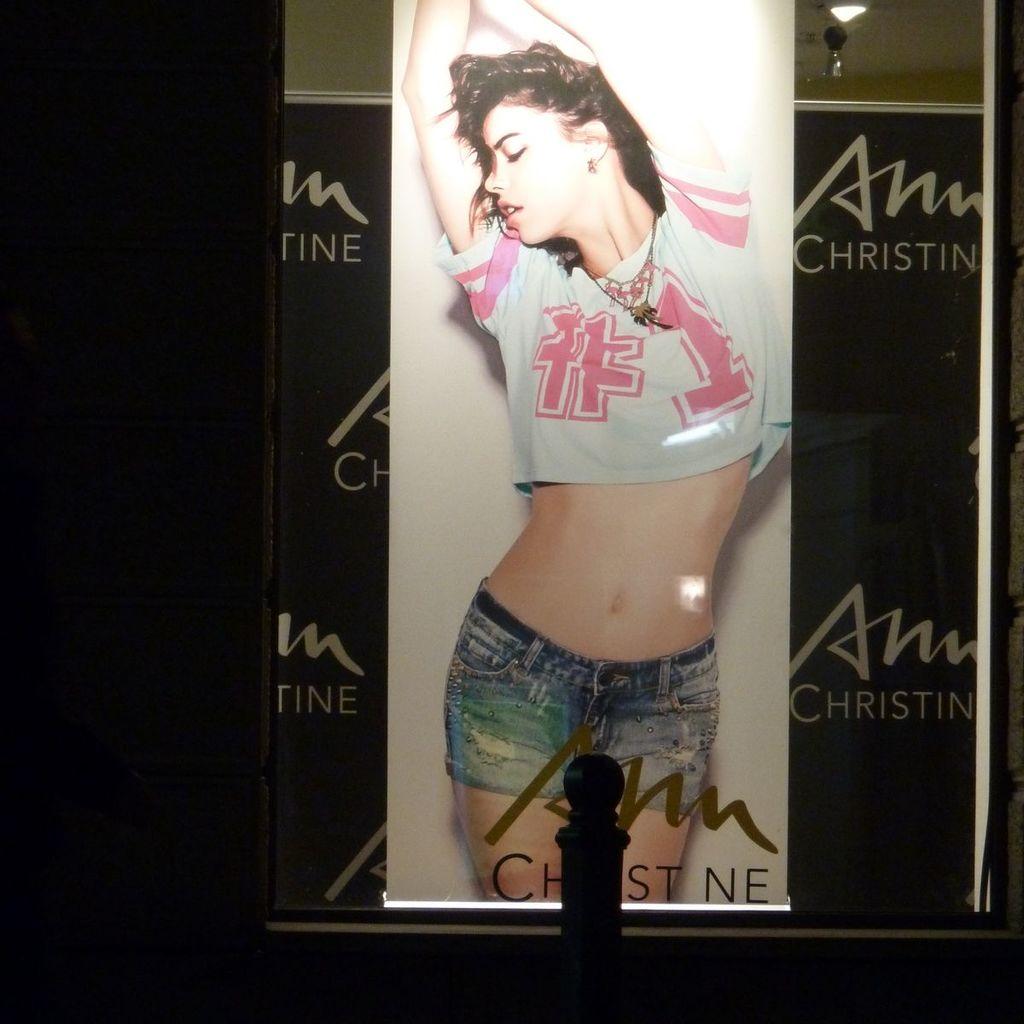What number is on her shirt?
Provide a succinct answer. 1. 